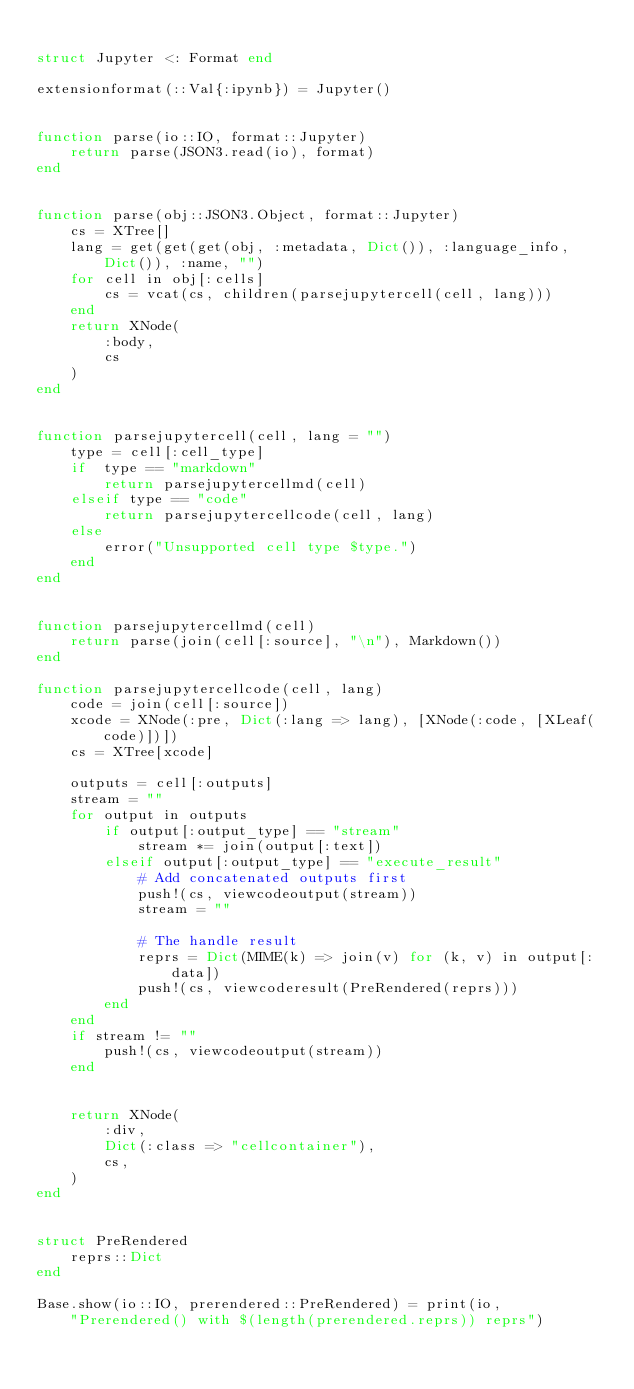Convert code to text. <code><loc_0><loc_0><loc_500><loc_500><_Julia_>
struct Jupyter <: Format end

extensionformat(::Val{:ipynb}) = Jupyter()


function parse(io::IO, format::Jupyter)
    return parse(JSON3.read(io), format)
end


function parse(obj::JSON3.Object, format::Jupyter)
    cs = XTree[]
    lang = get(get(get(obj, :metadata, Dict()), :language_info, Dict()), :name, "")
    for cell in obj[:cells]
        cs = vcat(cs, children(parsejupytercell(cell, lang)))
    end
    return XNode(
        :body,
        cs
    )
end


function parsejupytercell(cell, lang = "")
    type = cell[:cell_type]
    if  type == "markdown"
        return parsejupytercellmd(cell)
    elseif type == "code"
        return parsejupytercellcode(cell, lang)
    else
        error("Unsupported cell type $type.")
    end
end


function parsejupytercellmd(cell)
    return parse(join(cell[:source], "\n"), Markdown())
end

function parsejupytercellcode(cell, lang)
    code = join(cell[:source])
    xcode = XNode(:pre, Dict(:lang => lang), [XNode(:code, [XLeaf(code)])])
    cs = XTree[xcode]

    outputs = cell[:outputs]
    stream = ""
    for output in outputs
        if output[:output_type] == "stream"
            stream *= join(output[:text])
        elseif output[:output_type] == "execute_result"
            # Add concatenated outputs first
            push!(cs, viewcodeoutput(stream))
            stream = ""

            # The handle result
            reprs = Dict(MIME(k) => join(v) for (k, v) in output[:data])
            push!(cs, viewcoderesult(PreRendered(reprs)))
        end
    end
    if stream != ""
        push!(cs, viewcodeoutput(stream))
    end


    return XNode(
        :div,
        Dict(:class => "cellcontainer"),
        cs,
    )
end


struct PreRendered
    reprs::Dict
end

Base.show(io::IO, prerendered::PreRendered) = print(io,
    "Prerendered() with $(length(prerendered.reprs)) reprs")
</code> 